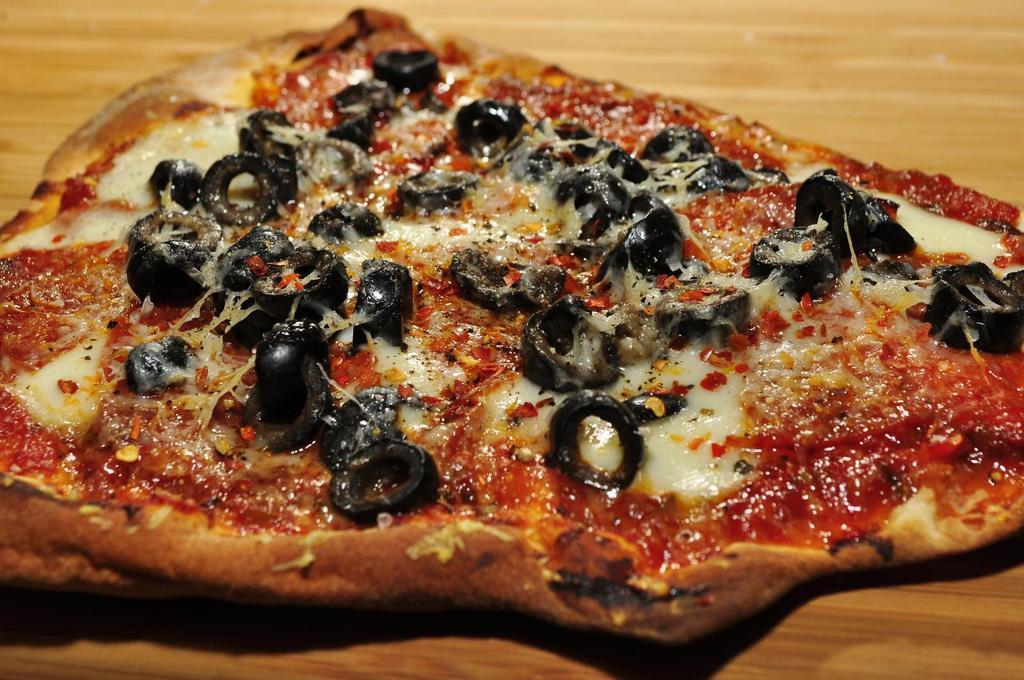What type of surface is visible in the image? There is a wooden surface in the image. What is placed on the wooden surface? There is a food item on the wooden surface. What is the black color thing on the food item? It is not specified what the black color thing is, but it is on the food item. What type of cheese is on the food item? There is cheese on the food item. What type of spice is on the food item? There are chilli flakes on the food item. What is the red color thing on the food item? It is not specified what the red color thing is, but it is on the food item. What type of spoon is used to play the record on the food item? There is no spoon or record present in the image; it features a food item with cheese, chilli flakes, and two unspecified color things. What type of star can be seen shining on the food item? There is no star present in the image; it features a food item with cheese, chilli flakes, and two unspecified color things. 